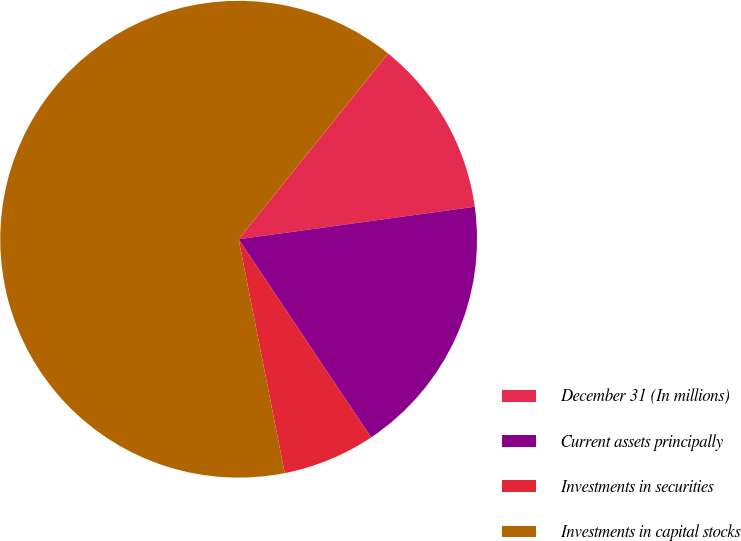Convert chart to OTSL. <chart><loc_0><loc_0><loc_500><loc_500><pie_chart><fcel>December 31 (In millions)<fcel>Current assets principally<fcel>Investments in securities<fcel>Investments in capital stocks<nl><fcel>12.04%<fcel>17.8%<fcel>6.28%<fcel>63.88%<nl></chart> 